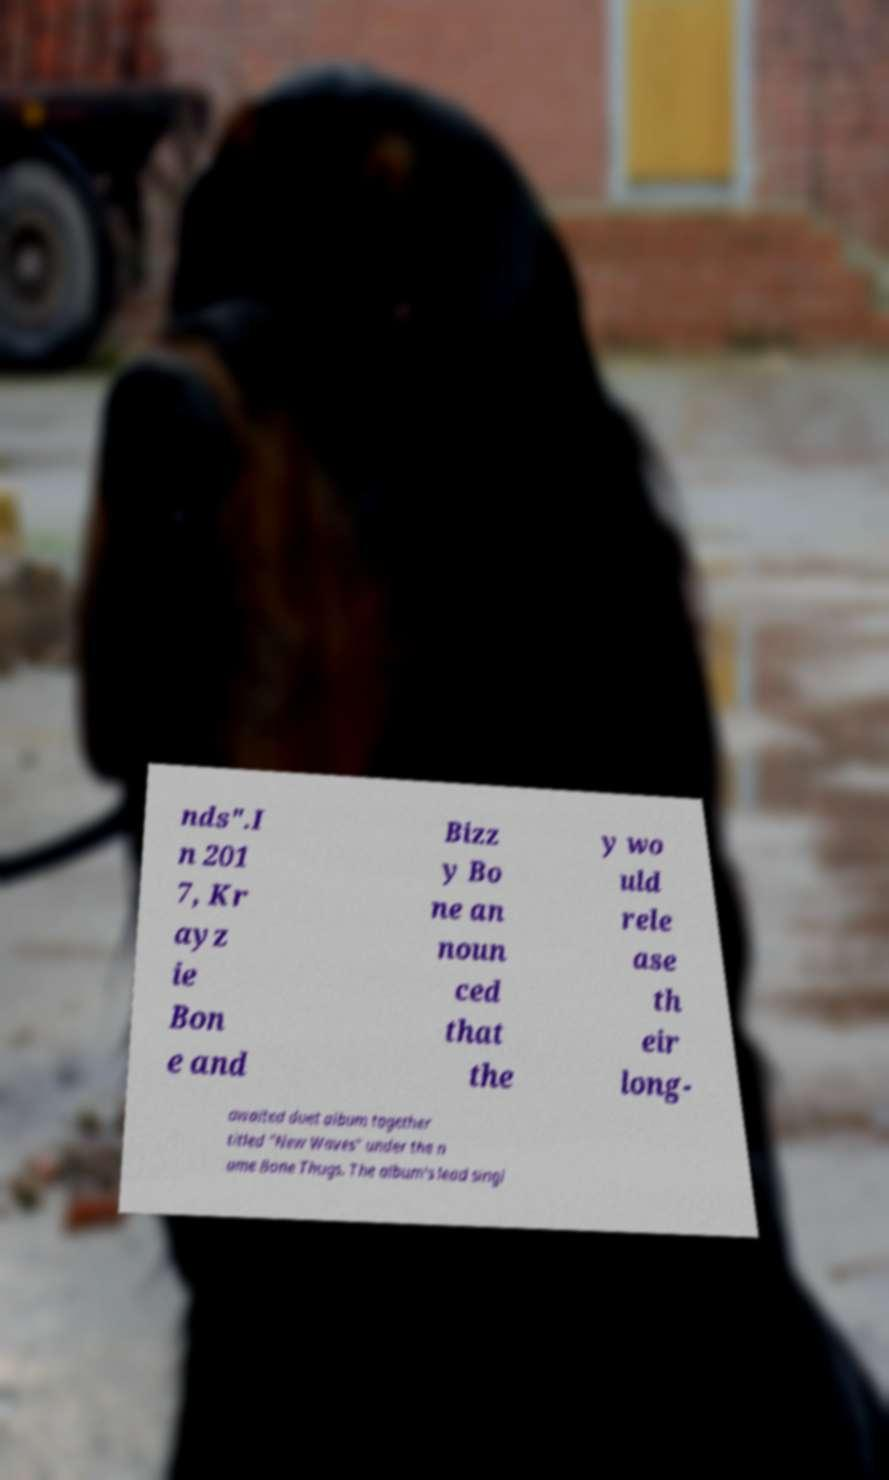Could you extract and type out the text from this image? nds".I n 201 7, Kr ayz ie Bon e and Bizz y Bo ne an noun ced that the y wo uld rele ase th eir long- awaited duet album together titled "New Waves" under the n ame Bone Thugs. The album's lead singl 